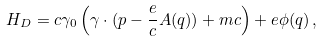Convert formula to latex. <formula><loc_0><loc_0><loc_500><loc_500>H _ { D } = c \gamma _ { 0 } \left ( \gamma \cdot ( p - \frac { e } { c } A ( q ) ) + m c \right ) + e \phi ( q ) \, ,</formula> 